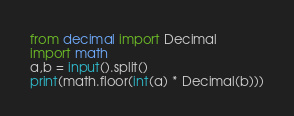<code> <loc_0><loc_0><loc_500><loc_500><_Python_>from decimal import Decimal
import math
a,b = input().split()
print(math.floor(int(a) * Decimal(b)))</code> 